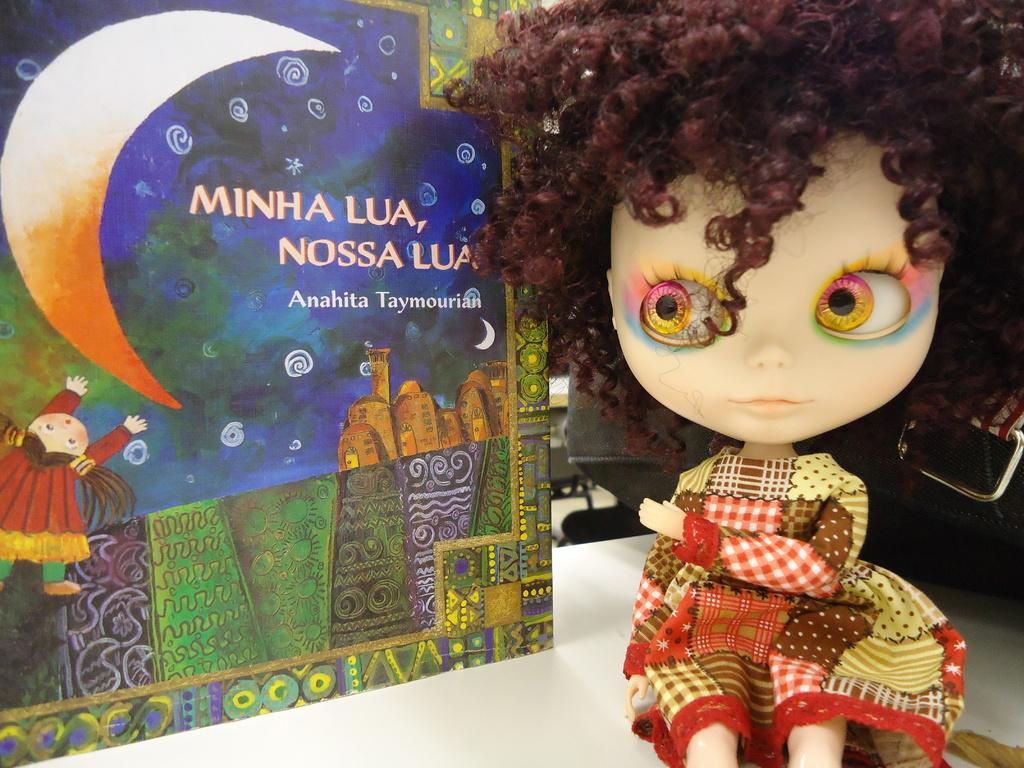What is the main subject of the image? There is a small doll in the image. Where is the doll located? The doll is sitting on a white table top. What else can be seen in the image besides the doll? There is a colorful poster in the image. What colors are present on the poster? The poster has green and blue colors. How many lettuce leaves are on the fork in the image? There is no fork or lettuce present in the image. 